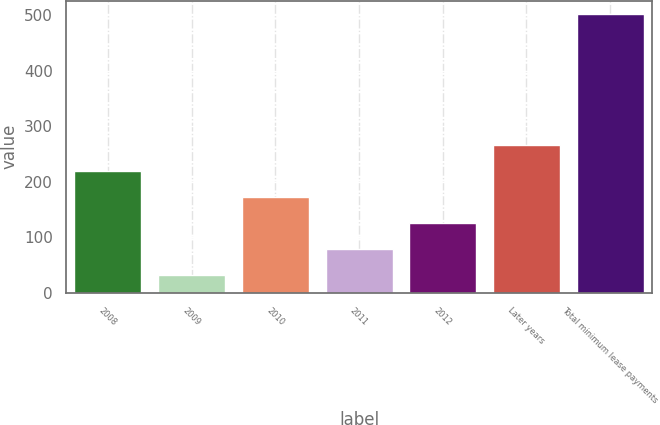<chart> <loc_0><loc_0><loc_500><loc_500><bar_chart><fcel>2008<fcel>2009<fcel>2010<fcel>2011<fcel>2012<fcel>Later years<fcel>Total minimum lease payments<nl><fcel>219.6<fcel>32<fcel>172.7<fcel>78.9<fcel>125.8<fcel>266.5<fcel>501<nl></chart> 